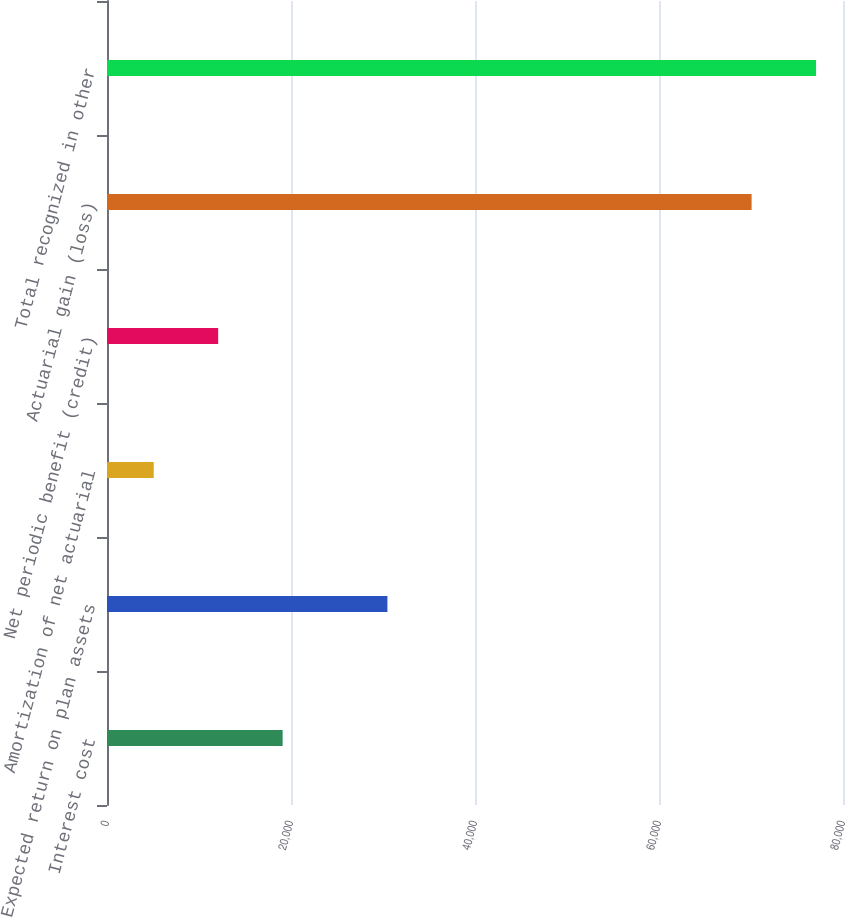<chart> <loc_0><loc_0><loc_500><loc_500><bar_chart><fcel>Interest cost<fcel>Expected return on plan assets<fcel>Amortization of net actuarial<fcel>Net periodic benefit (credit)<fcel>Actuarial gain (loss)<fcel>Total recognized in other<nl><fcel>19091<fcel>30480<fcel>5078<fcel>12084.5<fcel>70065<fcel>77071.5<nl></chart> 